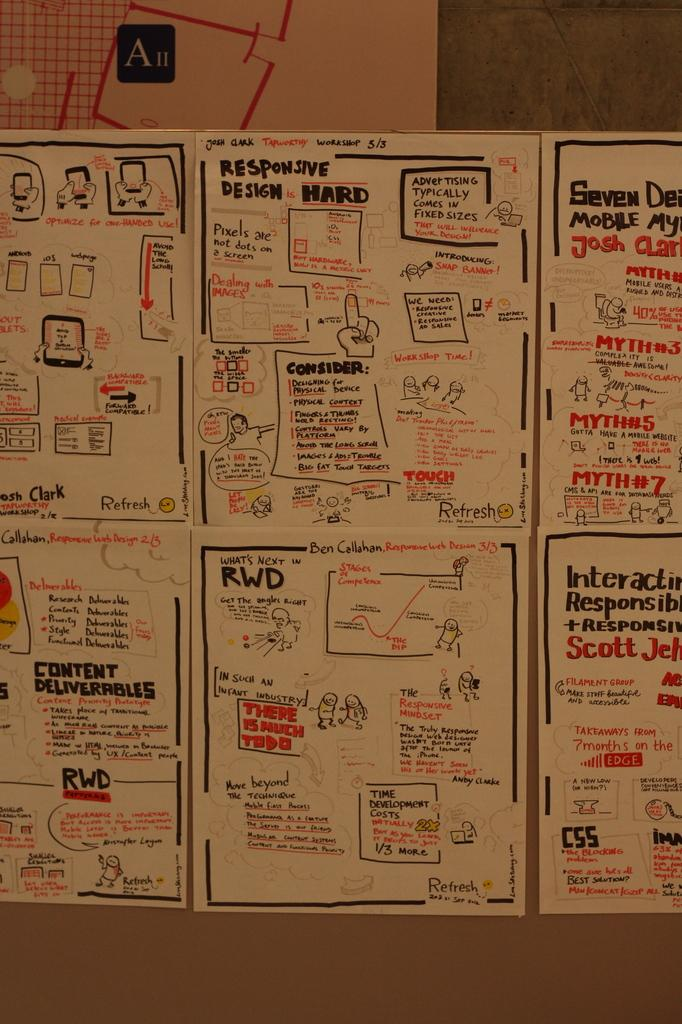<image>
Create a compact narrative representing the image presented. A row of illustrated papers with the top center paper titled Responsive design Hard 